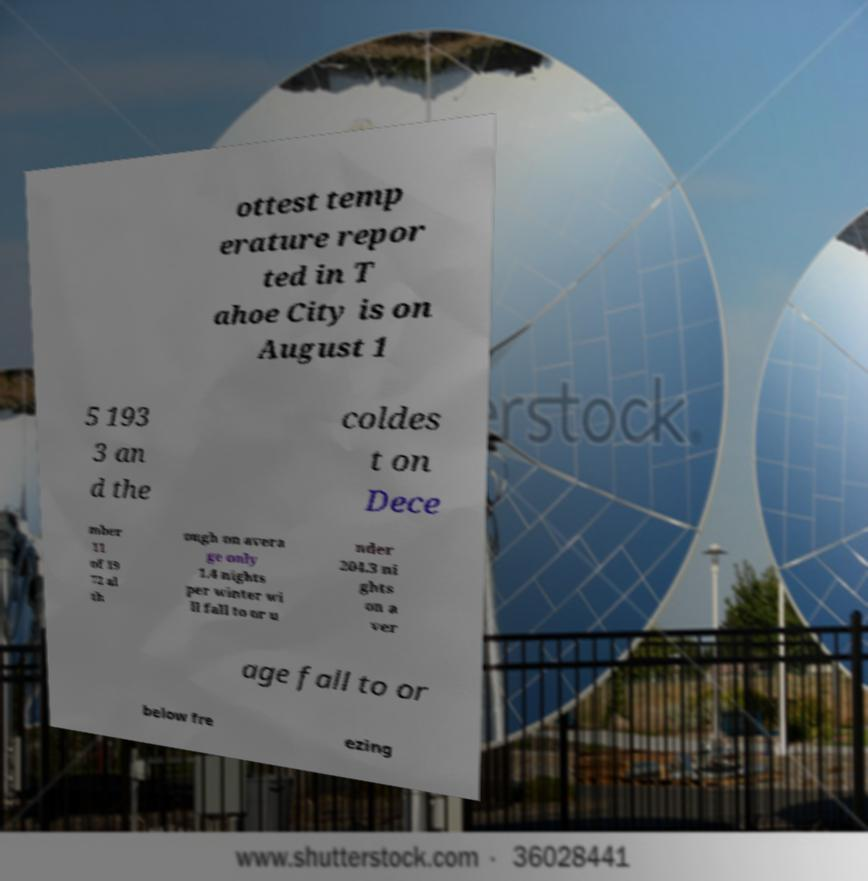For documentation purposes, I need the text within this image transcribed. Could you provide that? ottest temp erature repor ted in T ahoe City is on August 1 5 193 3 an d the coldes t on Dece mber 11 of 19 72 al th ough on avera ge only 1.4 nights per winter wi ll fall to or u nder 204.3 ni ghts on a ver age fall to or below fre ezing 